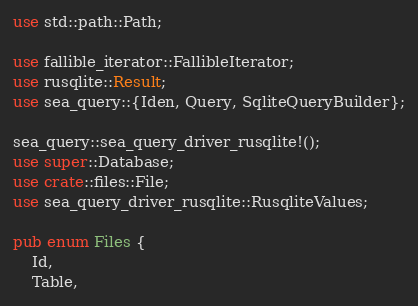Convert code to text. <code><loc_0><loc_0><loc_500><loc_500><_Rust_>use std::path::Path;

use fallible_iterator::FallibleIterator;
use rusqlite::Result;
use sea_query::{Iden, Query, SqliteQueryBuilder};

sea_query::sea_query_driver_rusqlite!();
use super::Database;
use crate::files::File;
use sea_query_driver_rusqlite::RusqliteValues;

pub enum Files {
    Id,
    Table,</code> 